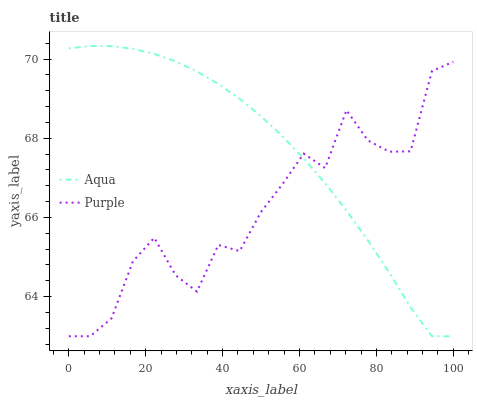Does Purple have the minimum area under the curve?
Answer yes or no. Yes. Does Aqua have the maximum area under the curve?
Answer yes or no. Yes. Does Aqua have the minimum area under the curve?
Answer yes or no. No. Is Aqua the smoothest?
Answer yes or no. Yes. Is Purple the roughest?
Answer yes or no. Yes. Is Aqua the roughest?
Answer yes or no. No. Does Purple have the lowest value?
Answer yes or no. Yes. Does Aqua have the highest value?
Answer yes or no. Yes. Does Aqua intersect Purple?
Answer yes or no. Yes. Is Aqua less than Purple?
Answer yes or no. No. Is Aqua greater than Purple?
Answer yes or no. No. 